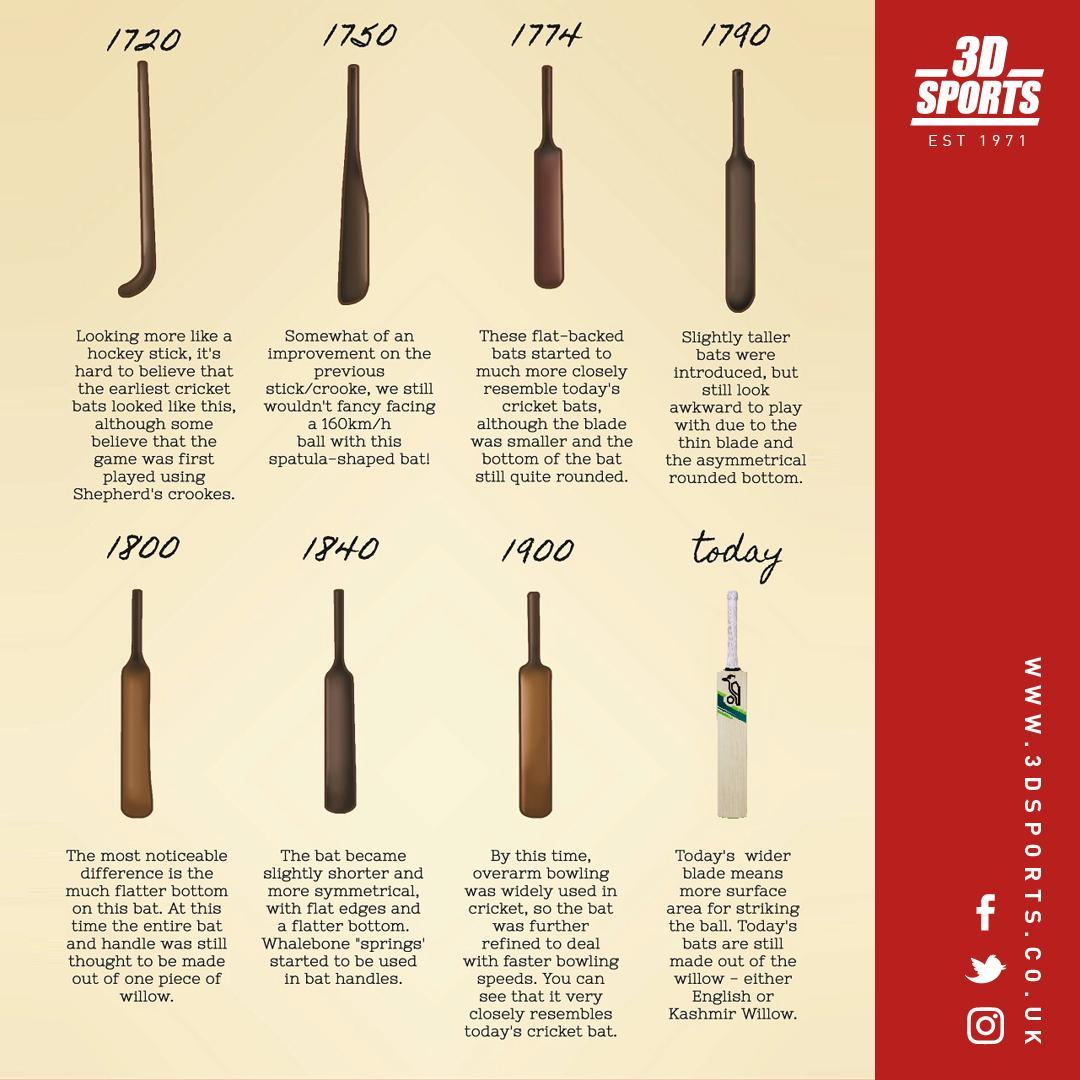In which year the cricket game played using flat-backed bats?
Answer the question with a short phrase. 1774 In which year Whalebone Springs started to be used in bat handles? 1840 In which year the cricket game played using Shepherd's Crookes? 1720 In which year the cricket game played using a Spatula-shaped bat? 1750 